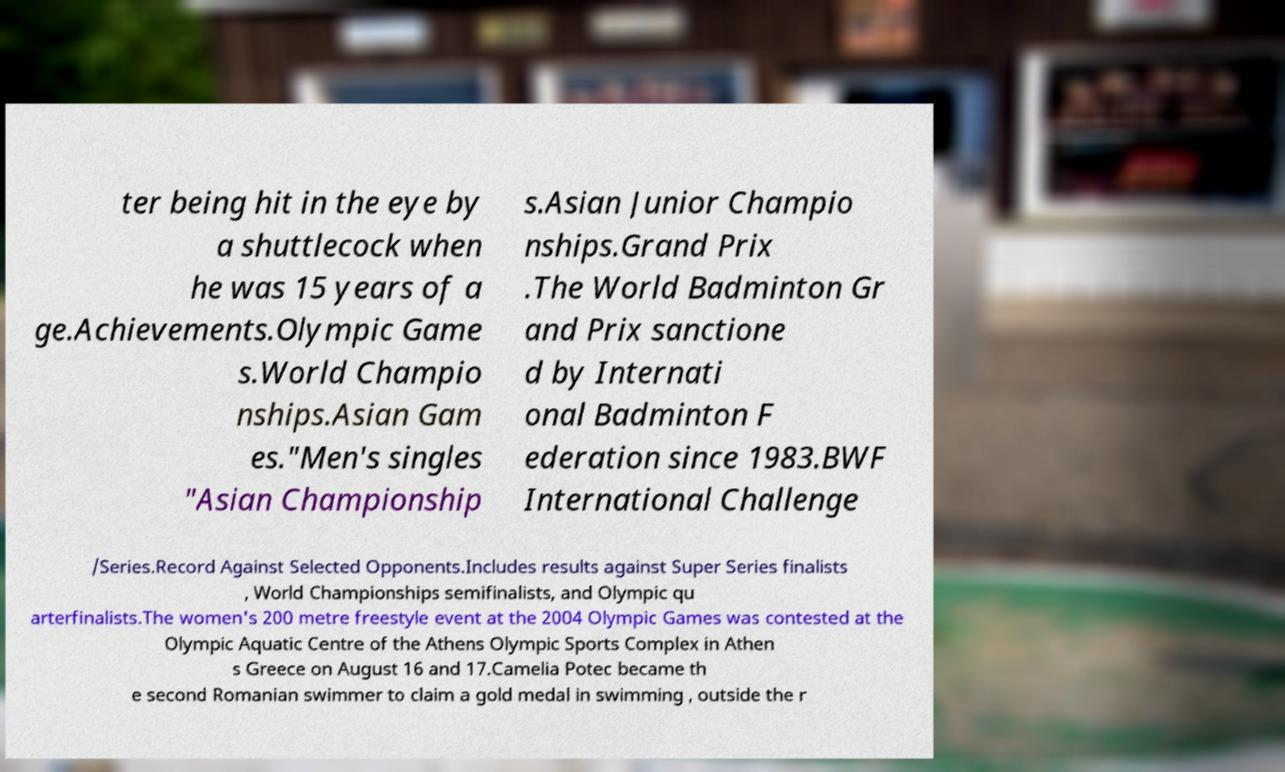What messages or text are displayed in this image? I need them in a readable, typed format. ter being hit in the eye by a shuttlecock when he was 15 years of a ge.Achievements.Olympic Game s.World Champio nships.Asian Gam es."Men's singles "Asian Championship s.Asian Junior Champio nships.Grand Prix .The World Badminton Gr and Prix sanctione d by Internati onal Badminton F ederation since 1983.BWF International Challenge /Series.Record Against Selected Opponents.Includes results against Super Series finalists , World Championships semifinalists, and Olympic qu arterfinalists.The women's 200 metre freestyle event at the 2004 Olympic Games was contested at the Olympic Aquatic Centre of the Athens Olympic Sports Complex in Athen s Greece on August 16 and 17.Camelia Potec became th e second Romanian swimmer to claim a gold medal in swimming , outside the r 